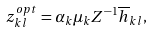Convert formula to latex. <formula><loc_0><loc_0><loc_500><loc_500>z _ { k l } ^ { o p t } = { \alpha _ { k } { \mu } _ { k } { Z } ^ { - 1 } \overline { h } _ { k l } } ,</formula> 